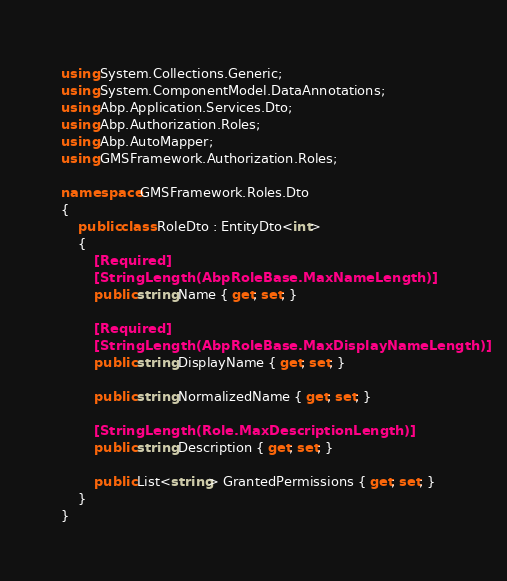Convert code to text. <code><loc_0><loc_0><loc_500><loc_500><_C#_>using System.Collections.Generic;
using System.ComponentModel.DataAnnotations;
using Abp.Application.Services.Dto;
using Abp.Authorization.Roles;
using Abp.AutoMapper;
using GMSFramework.Authorization.Roles;

namespace GMSFramework.Roles.Dto
{
    public class RoleDto : EntityDto<int>
    {
        [Required]
        [StringLength(AbpRoleBase.MaxNameLength)]
        public string Name { get; set; }
        
        [Required]
        [StringLength(AbpRoleBase.MaxDisplayNameLength)]
        public string DisplayName { get; set; }

        public string NormalizedName { get; set; }
        
        [StringLength(Role.MaxDescriptionLength)]
        public string Description { get; set; }

        public List<string> GrantedPermissions { get; set; }
    }
}</code> 